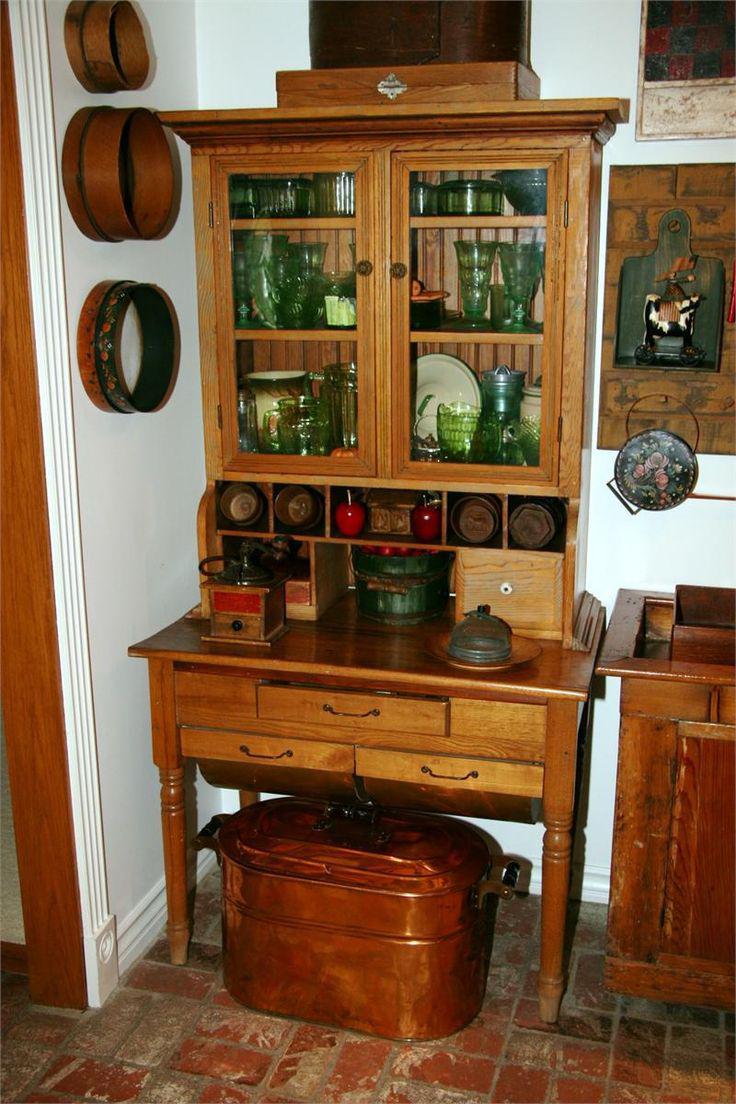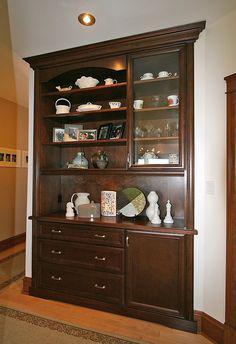The first image is the image on the left, the second image is the image on the right. Analyze the images presented: Is the assertion "There is at least one deep red cabinet with legs." valid? Answer yes or no. No. The first image is the image on the left, the second image is the image on the right. Evaluate the accuracy of this statement regarding the images: "there are two cabinets on the bottom of the hutch on the right". Is it true? Answer yes or no. No. 